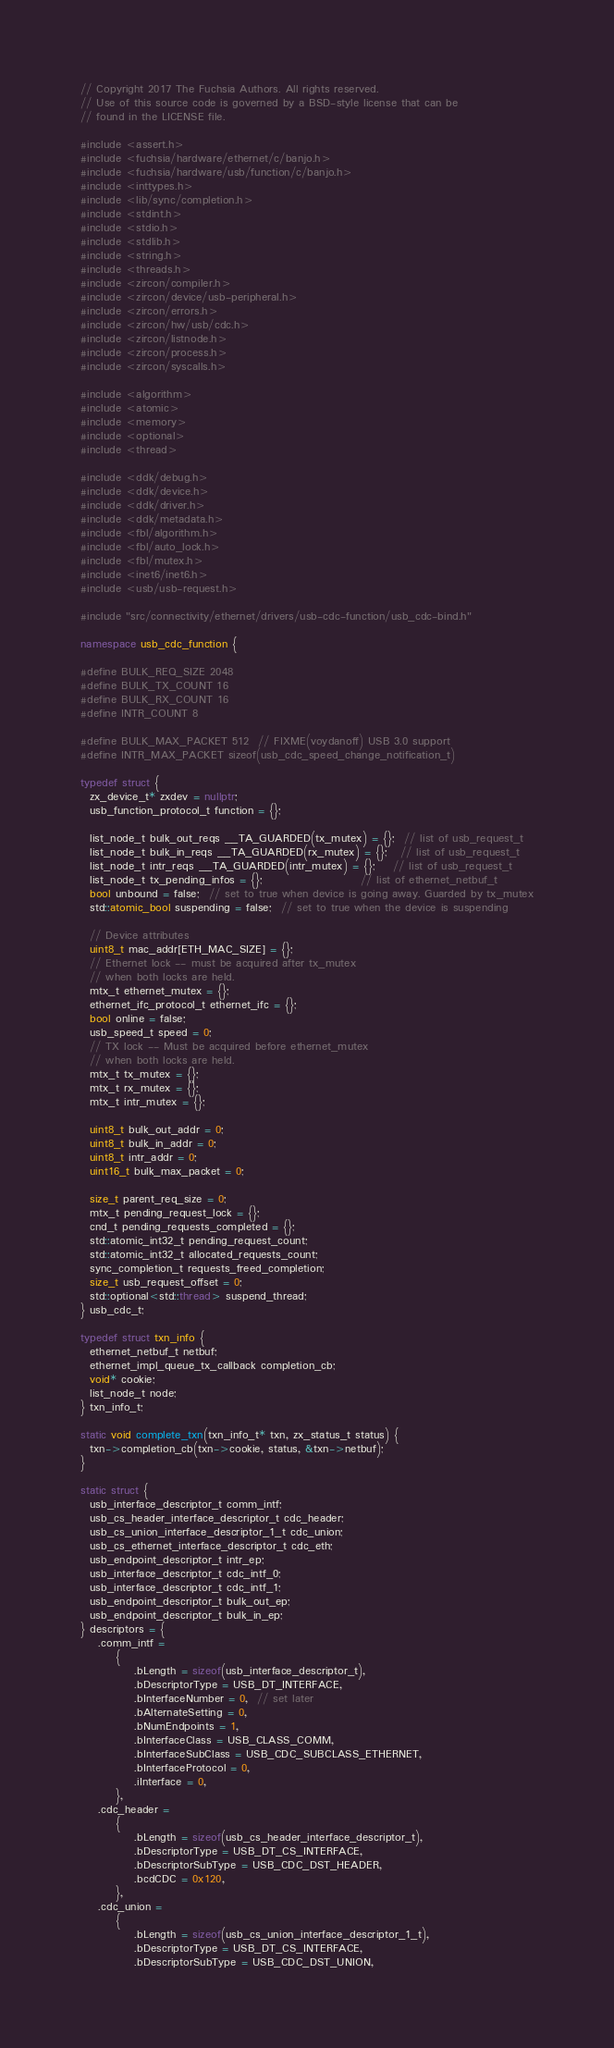Convert code to text. <code><loc_0><loc_0><loc_500><loc_500><_C++_>// Copyright 2017 The Fuchsia Authors. All rights reserved.
// Use of this source code is governed by a BSD-style license that can be
// found in the LICENSE file.

#include <assert.h>
#include <fuchsia/hardware/ethernet/c/banjo.h>
#include <fuchsia/hardware/usb/function/c/banjo.h>
#include <inttypes.h>
#include <lib/sync/completion.h>
#include <stdint.h>
#include <stdio.h>
#include <stdlib.h>
#include <string.h>
#include <threads.h>
#include <zircon/compiler.h>
#include <zircon/device/usb-peripheral.h>
#include <zircon/errors.h>
#include <zircon/hw/usb/cdc.h>
#include <zircon/listnode.h>
#include <zircon/process.h>
#include <zircon/syscalls.h>

#include <algorithm>
#include <atomic>
#include <memory>
#include <optional>
#include <thread>

#include <ddk/debug.h>
#include <ddk/device.h>
#include <ddk/driver.h>
#include <ddk/metadata.h>
#include <fbl/algorithm.h>
#include <fbl/auto_lock.h>
#include <fbl/mutex.h>
#include <inet6/inet6.h>
#include <usb/usb-request.h>

#include "src/connectivity/ethernet/drivers/usb-cdc-function/usb_cdc-bind.h"

namespace usb_cdc_function {

#define BULK_REQ_SIZE 2048
#define BULK_TX_COUNT 16
#define BULK_RX_COUNT 16
#define INTR_COUNT 8

#define BULK_MAX_PACKET 512  // FIXME(voydanoff) USB 3.0 support
#define INTR_MAX_PACKET sizeof(usb_cdc_speed_change_notification_t)

typedef struct {
  zx_device_t* zxdev = nullptr;
  usb_function_protocol_t function = {};

  list_node_t bulk_out_reqs __TA_GUARDED(tx_mutex) = {};  // list of usb_request_t
  list_node_t bulk_in_reqs __TA_GUARDED(rx_mutex) = {};   // list of usb_request_t
  list_node_t intr_reqs __TA_GUARDED(intr_mutex) = {};    // list of usb_request_t
  list_node_t tx_pending_infos = {};                      // list of ethernet_netbuf_t
  bool unbound = false;  // set to true when device is going away. Guarded by tx_mutex
  std::atomic_bool suspending = false;  // set to true when the device is suspending

  // Device attributes
  uint8_t mac_addr[ETH_MAC_SIZE] = {};
  // Ethernet lock -- must be acquired after tx_mutex
  // when both locks are held.
  mtx_t ethernet_mutex = {};
  ethernet_ifc_protocol_t ethernet_ifc = {};
  bool online = false;
  usb_speed_t speed = 0;
  // TX lock -- Must be acquired before ethernet_mutex
  // when both locks are held.
  mtx_t tx_mutex = {};
  mtx_t rx_mutex = {};
  mtx_t intr_mutex = {};

  uint8_t bulk_out_addr = 0;
  uint8_t bulk_in_addr = 0;
  uint8_t intr_addr = 0;
  uint16_t bulk_max_packet = 0;

  size_t parent_req_size = 0;
  mtx_t pending_request_lock = {};
  cnd_t pending_requests_completed = {};
  std::atomic_int32_t pending_request_count;
  std::atomic_int32_t allocated_requests_count;
  sync_completion_t requests_freed_completion;
  size_t usb_request_offset = 0;
  std::optional<std::thread> suspend_thread;
} usb_cdc_t;

typedef struct txn_info {
  ethernet_netbuf_t netbuf;
  ethernet_impl_queue_tx_callback completion_cb;
  void* cookie;
  list_node_t node;
} txn_info_t;

static void complete_txn(txn_info_t* txn, zx_status_t status) {
  txn->completion_cb(txn->cookie, status, &txn->netbuf);
}

static struct {
  usb_interface_descriptor_t comm_intf;
  usb_cs_header_interface_descriptor_t cdc_header;
  usb_cs_union_interface_descriptor_1_t cdc_union;
  usb_cs_ethernet_interface_descriptor_t cdc_eth;
  usb_endpoint_descriptor_t intr_ep;
  usb_interface_descriptor_t cdc_intf_0;
  usb_interface_descriptor_t cdc_intf_1;
  usb_endpoint_descriptor_t bulk_out_ep;
  usb_endpoint_descriptor_t bulk_in_ep;
} descriptors = {
    .comm_intf =
        {
            .bLength = sizeof(usb_interface_descriptor_t),
            .bDescriptorType = USB_DT_INTERFACE,
            .bInterfaceNumber = 0,  // set later
            .bAlternateSetting = 0,
            .bNumEndpoints = 1,
            .bInterfaceClass = USB_CLASS_COMM,
            .bInterfaceSubClass = USB_CDC_SUBCLASS_ETHERNET,
            .bInterfaceProtocol = 0,
            .iInterface = 0,
        },
    .cdc_header =
        {
            .bLength = sizeof(usb_cs_header_interface_descriptor_t),
            .bDescriptorType = USB_DT_CS_INTERFACE,
            .bDescriptorSubType = USB_CDC_DST_HEADER,
            .bcdCDC = 0x120,
        },
    .cdc_union =
        {
            .bLength = sizeof(usb_cs_union_interface_descriptor_1_t),
            .bDescriptorType = USB_DT_CS_INTERFACE,
            .bDescriptorSubType = USB_CDC_DST_UNION,</code> 